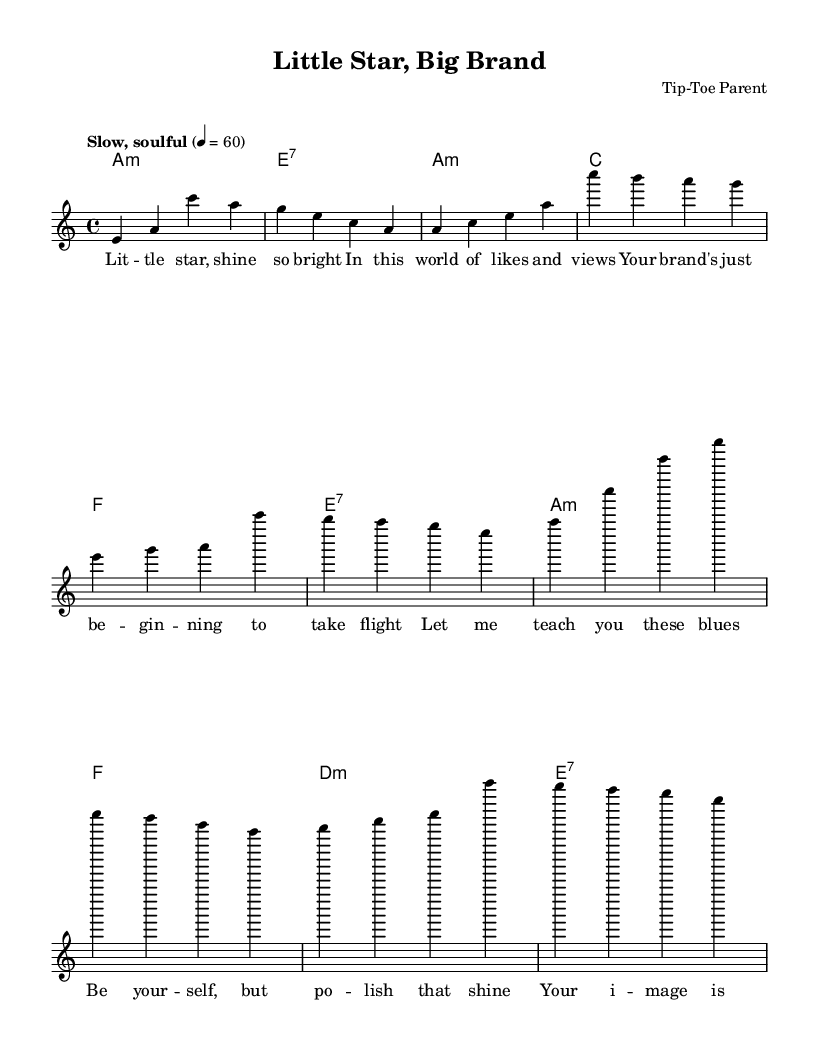What is the key signature of this music? The key signature is indicated by the presence of one flat (B flat) in the piece, which is characteristic of the A minor scale.
Answer: A minor What is the time signature of this piece? The time signature is found next to the clef at the beginning of the sheet music and indicates how many beats are in each measure. Here, it shows 4/4, meaning there are 4 beats per measure.
Answer: 4/4 What is the tempo marking of this piece? The tempo marking is noted at the beginning of the score, stating the speed and character of the music. It states "Slow, soulful," which indicates the mood and pace to be conveyed during performance.
Answer: Slow, soulful How many measures are in the verse section? By examining the structure of the melody, we can count the number of measures labeled as part of the verse. There are a total of 4 measures present in the verse section before the chorus begins.
Answer: 4 Which scale degrees are primarily used in the chorus? The chorus seems to strongly utilize the notes A, C, E, G, and B, which correspond to primary degrees of the A minor scale, emphasizing the tonal structure typical of blues music. This can be thought about in the context of the chords played during the chorus as well.
Answer: A, C, E, G, B What type of chord followed the introduction? The introduction features an A minor chord followed by an E7 chord. Specifically focusing on the immediate chord following the introduction, it is an A minor chord which delivers a strong and soulful accent typical of blues.
Answer: A minor 